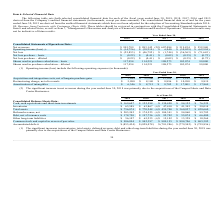From Extreme Networks's financial document, Which years does the table provide information for the company's audited financial statements? The document contains multiple relevant values: 2019, 2018, 2017, 2016, 2015. From the document: "2019 2018 2017 2016 2015 2019 2018 2017 2016 2015 2019 2018 2017 2016 2015 2019 2018 2017 2016 2015 2019 2018 2017 2016 2015..." Also, What was the net revenues in 2015? According to the financial document, 552,940 (in thousands). The relevant text states: "nues $ 995,789 $ 983,142 (2)$ 607,084 $ 519,834 $ 552,940..." Also, What was the net loss in 2019? According to the financial document, (25,853) (in thousands). The relevant text states: "Net loss $ (25,853) $ (46,792) $ (1,744) $ (36,363) $ (71,643)..." Also, How many years did the net revenues exceed $700,000 thousand? Counting the relevant items in the document: 2019, 2018, I find 2 instances. The key data points involved are: 2018, 2019. Also, can you calculate: What was the change in the basic shares used in per share calculation between 2017 and 2018? Based on the calculation: 114,221-108,273, the result is 5948 (in thousands). This is based on the information: "in per share calculation – basic 117,954 114,221 108,273 103,074 99,000 res used in per share calculation – basic 117,954 114,221 108,273 103,074 99,000..." The key data points involved are: 108,273, 114,221. Also, can you calculate: What was the percentage change in the basic net loss per share between 2018 and 2019? To answer this question, I need to perform calculations using the financial data. The calculation is: (-0.22+0.41)/-0.41, which equals -46.34 (percentage). This is based on the information: "Net loss per share – basic $ (0.22) $ (0.41) $ (0.02) $ (0.35) $ (0.72) Net loss per share – basic $ (0.22) $ (0.41) $ (0.02) $ (0.35) $ (0.72)..." The key data points involved are: 0.22, 0.41. 